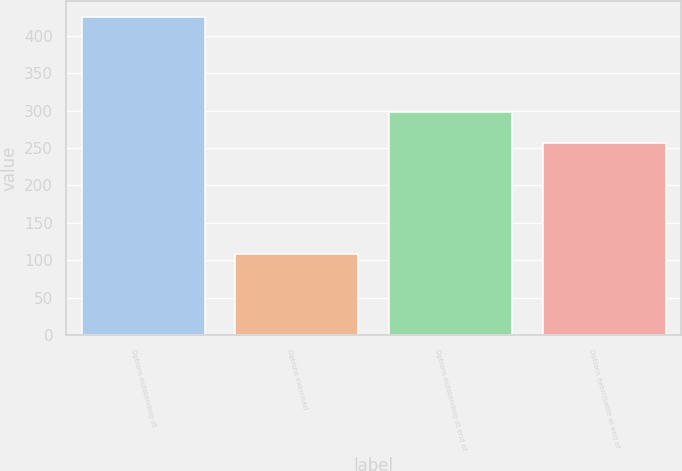<chart> <loc_0><loc_0><loc_500><loc_500><bar_chart><fcel>Options outstanding at<fcel>Options exercised<fcel>Options outstanding at end of<fcel>Options exercisable at end of<nl><fcel>425<fcel>108<fcel>298<fcel>257<nl></chart> 